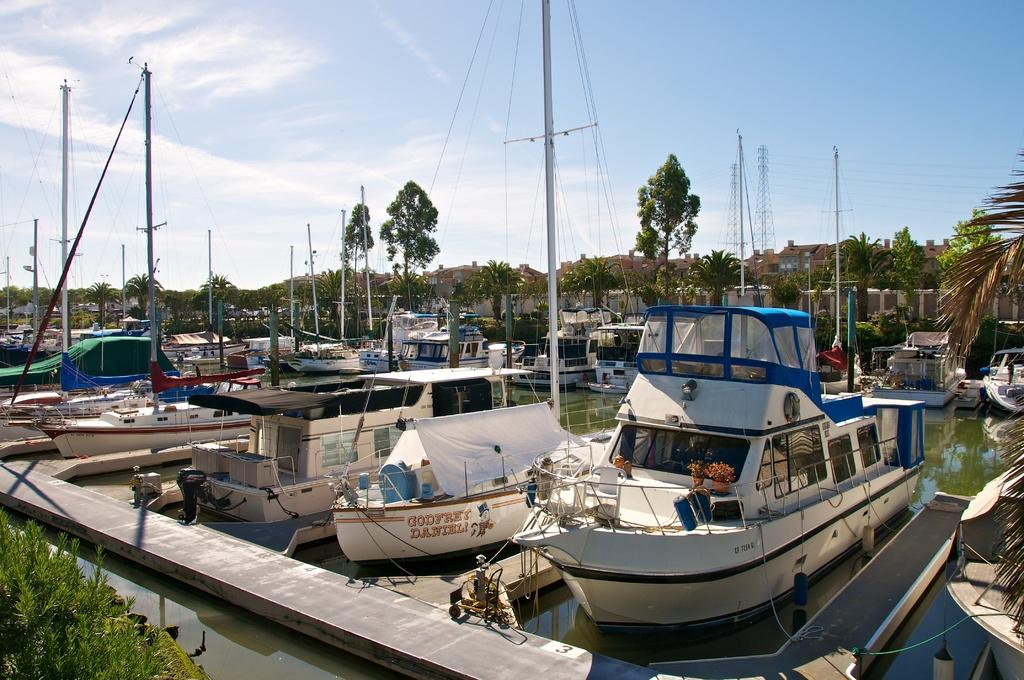What is on the water in the image? There are boats on the water in the image. What can be seen in the background of the image? There are trees, houses, and towers visible in the background of the image. What type of plant is growing on the dock in the image? There is no dock present in the image, so it is not possible to determine if any plants are growing on it. 